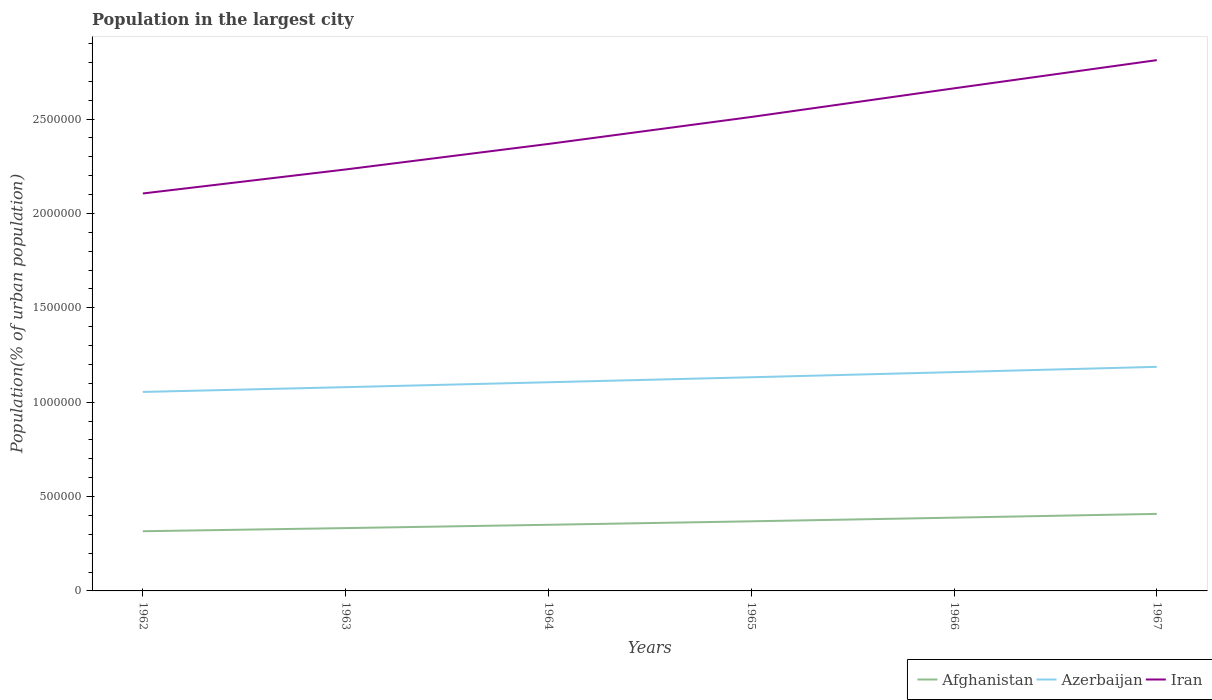How many different coloured lines are there?
Offer a terse response. 3. Does the line corresponding to Afghanistan intersect with the line corresponding to Iran?
Provide a succinct answer. No. Is the number of lines equal to the number of legend labels?
Your answer should be very brief. Yes. Across all years, what is the maximum population in the largest city in Iran?
Keep it short and to the point. 2.11e+06. In which year was the population in the largest city in Afghanistan maximum?
Your response must be concise. 1962. What is the total population in the largest city in Iran in the graph?
Offer a very short reply. -2.78e+05. What is the difference between the highest and the second highest population in the largest city in Azerbaijan?
Ensure brevity in your answer.  1.33e+05. What is the difference between the highest and the lowest population in the largest city in Iran?
Your response must be concise. 3. What is the difference between two consecutive major ticks on the Y-axis?
Ensure brevity in your answer.  5.00e+05. Does the graph contain any zero values?
Make the answer very short. No. How many legend labels are there?
Your response must be concise. 3. What is the title of the graph?
Provide a short and direct response. Population in the largest city. Does "Vietnam" appear as one of the legend labels in the graph?
Make the answer very short. No. What is the label or title of the Y-axis?
Keep it short and to the point. Population(% of urban population). What is the Population(% of urban population) of Afghanistan in 1962?
Offer a terse response. 3.16e+05. What is the Population(% of urban population) of Azerbaijan in 1962?
Make the answer very short. 1.05e+06. What is the Population(% of urban population) of Iran in 1962?
Your answer should be compact. 2.11e+06. What is the Population(% of urban population) of Afghanistan in 1963?
Offer a very short reply. 3.33e+05. What is the Population(% of urban population) of Azerbaijan in 1963?
Provide a succinct answer. 1.08e+06. What is the Population(% of urban population) of Iran in 1963?
Offer a very short reply. 2.23e+06. What is the Population(% of urban population) of Afghanistan in 1964?
Your response must be concise. 3.50e+05. What is the Population(% of urban population) in Azerbaijan in 1964?
Provide a succinct answer. 1.11e+06. What is the Population(% of urban population) of Iran in 1964?
Your answer should be very brief. 2.37e+06. What is the Population(% of urban population) of Afghanistan in 1965?
Provide a succinct answer. 3.69e+05. What is the Population(% of urban population) of Azerbaijan in 1965?
Your answer should be very brief. 1.13e+06. What is the Population(% of urban population) in Iran in 1965?
Offer a terse response. 2.51e+06. What is the Population(% of urban population) of Afghanistan in 1966?
Offer a terse response. 3.88e+05. What is the Population(% of urban population) in Azerbaijan in 1966?
Keep it short and to the point. 1.16e+06. What is the Population(% of urban population) in Iran in 1966?
Offer a very short reply. 2.66e+06. What is the Population(% of urban population) in Afghanistan in 1967?
Ensure brevity in your answer.  4.08e+05. What is the Population(% of urban population) in Azerbaijan in 1967?
Your answer should be very brief. 1.19e+06. What is the Population(% of urban population) of Iran in 1967?
Provide a short and direct response. 2.81e+06. Across all years, what is the maximum Population(% of urban population) of Afghanistan?
Keep it short and to the point. 4.08e+05. Across all years, what is the maximum Population(% of urban population) in Azerbaijan?
Your answer should be very brief. 1.19e+06. Across all years, what is the maximum Population(% of urban population) in Iran?
Keep it short and to the point. 2.81e+06. Across all years, what is the minimum Population(% of urban population) in Afghanistan?
Your answer should be compact. 3.16e+05. Across all years, what is the minimum Population(% of urban population) in Azerbaijan?
Provide a succinct answer. 1.05e+06. Across all years, what is the minimum Population(% of urban population) of Iran?
Your answer should be compact. 2.11e+06. What is the total Population(% of urban population) of Afghanistan in the graph?
Your response must be concise. 2.16e+06. What is the total Population(% of urban population) in Azerbaijan in the graph?
Ensure brevity in your answer.  6.72e+06. What is the total Population(% of urban population) of Iran in the graph?
Make the answer very short. 1.47e+07. What is the difference between the Population(% of urban population) of Afghanistan in 1962 and that in 1963?
Provide a short and direct response. -1.67e+04. What is the difference between the Population(% of urban population) in Azerbaijan in 1962 and that in 1963?
Provide a succinct answer. -2.53e+04. What is the difference between the Population(% of urban population) in Iran in 1962 and that in 1963?
Your response must be concise. -1.27e+05. What is the difference between the Population(% of urban population) of Afghanistan in 1962 and that in 1964?
Keep it short and to the point. -3.42e+04. What is the difference between the Population(% of urban population) in Azerbaijan in 1962 and that in 1964?
Your response must be concise. -5.13e+04. What is the difference between the Population(% of urban population) of Iran in 1962 and that in 1964?
Offer a very short reply. -2.62e+05. What is the difference between the Population(% of urban population) of Afghanistan in 1962 and that in 1965?
Make the answer very short. -5.26e+04. What is the difference between the Population(% of urban population) of Azerbaijan in 1962 and that in 1965?
Your response must be concise. -7.79e+04. What is the difference between the Population(% of urban population) in Iran in 1962 and that in 1965?
Offer a terse response. -4.05e+05. What is the difference between the Population(% of urban population) in Afghanistan in 1962 and that in 1966?
Provide a succinct answer. -7.21e+04. What is the difference between the Population(% of urban population) in Azerbaijan in 1962 and that in 1966?
Make the answer very short. -1.05e+05. What is the difference between the Population(% of urban population) of Iran in 1962 and that in 1966?
Give a very brief answer. -5.57e+05. What is the difference between the Population(% of urban population) in Afghanistan in 1962 and that in 1967?
Provide a short and direct response. -9.19e+04. What is the difference between the Population(% of urban population) of Azerbaijan in 1962 and that in 1967?
Provide a succinct answer. -1.33e+05. What is the difference between the Population(% of urban population) in Iran in 1962 and that in 1967?
Offer a very short reply. -7.06e+05. What is the difference between the Population(% of urban population) in Afghanistan in 1963 and that in 1964?
Your answer should be very brief. -1.76e+04. What is the difference between the Population(% of urban population) in Azerbaijan in 1963 and that in 1964?
Your answer should be very brief. -2.60e+04. What is the difference between the Population(% of urban population) of Iran in 1963 and that in 1964?
Your response must be concise. -1.35e+05. What is the difference between the Population(% of urban population) of Afghanistan in 1963 and that in 1965?
Your answer should be very brief. -3.60e+04. What is the difference between the Population(% of urban population) of Azerbaijan in 1963 and that in 1965?
Ensure brevity in your answer.  -5.25e+04. What is the difference between the Population(% of urban population) in Iran in 1963 and that in 1965?
Your answer should be very brief. -2.78e+05. What is the difference between the Population(% of urban population) of Afghanistan in 1963 and that in 1966?
Ensure brevity in your answer.  -5.54e+04. What is the difference between the Population(% of urban population) in Azerbaijan in 1963 and that in 1966?
Your answer should be compact. -7.97e+04. What is the difference between the Population(% of urban population) of Iran in 1963 and that in 1966?
Give a very brief answer. -4.30e+05. What is the difference between the Population(% of urban population) in Afghanistan in 1963 and that in 1967?
Offer a terse response. -7.53e+04. What is the difference between the Population(% of urban population) in Azerbaijan in 1963 and that in 1967?
Give a very brief answer. -1.08e+05. What is the difference between the Population(% of urban population) in Iran in 1963 and that in 1967?
Make the answer very short. -5.79e+05. What is the difference between the Population(% of urban population) of Afghanistan in 1964 and that in 1965?
Keep it short and to the point. -1.84e+04. What is the difference between the Population(% of urban population) in Azerbaijan in 1964 and that in 1965?
Offer a very short reply. -2.65e+04. What is the difference between the Population(% of urban population) in Iran in 1964 and that in 1965?
Your answer should be very brief. -1.43e+05. What is the difference between the Population(% of urban population) in Afghanistan in 1964 and that in 1966?
Offer a very short reply. -3.78e+04. What is the difference between the Population(% of urban population) in Azerbaijan in 1964 and that in 1966?
Give a very brief answer. -5.37e+04. What is the difference between the Population(% of urban population) in Iran in 1964 and that in 1966?
Offer a terse response. -2.95e+05. What is the difference between the Population(% of urban population) of Afghanistan in 1964 and that in 1967?
Give a very brief answer. -5.77e+04. What is the difference between the Population(% of urban population) of Azerbaijan in 1964 and that in 1967?
Your answer should be compact. -8.16e+04. What is the difference between the Population(% of urban population) of Iran in 1964 and that in 1967?
Offer a terse response. -4.44e+05. What is the difference between the Population(% of urban population) of Afghanistan in 1965 and that in 1966?
Ensure brevity in your answer.  -1.94e+04. What is the difference between the Population(% of urban population) of Azerbaijan in 1965 and that in 1966?
Offer a terse response. -2.72e+04. What is the difference between the Population(% of urban population) in Iran in 1965 and that in 1966?
Offer a very short reply. -1.52e+05. What is the difference between the Population(% of urban population) of Afghanistan in 1965 and that in 1967?
Make the answer very short. -3.93e+04. What is the difference between the Population(% of urban population) of Azerbaijan in 1965 and that in 1967?
Your response must be concise. -5.51e+04. What is the difference between the Population(% of urban population) in Iran in 1965 and that in 1967?
Provide a succinct answer. -3.01e+05. What is the difference between the Population(% of urban population) of Afghanistan in 1966 and that in 1967?
Provide a succinct answer. -1.99e+04. What is the difference between the Population(% of urban population) of Azerbaijan in 1966 and that in 1967?
Make the answer very short. -2.79e+04. What is the difference between the Population(% of urban population) of Iran in 1966 and that in 1967?
Your answer should be very brief. -1.49e+05. What is the difference between the Population(% of urban population) of Afghanistan in 1962 and the Population(% of urban population) of Azerbaijan in 1963?
Provide a short and direct response. -7.63e+05. What is the difference between the Population(% of urban population) of Afghanistan in 1962 and the Population(% of urban population) of Iran in 1963?
Provide a succinct answer. -1.92e+06. What is the difference between the Population(% of urban population) in Azerbaijan in 1962 and the Population(% of urban population) in Iran in 1963?
Provide a short and direct response. -1.18e+06. What is the difference between the Population(% of urban population) in Afghanistan in 1962 and the Population(% of urban population) in Azerbaijan in 1964?
Your response must be concise. -7.89e+05. What is the difference between the Population(% of urban population) in Afghanistan in 1962 and the Population(% of urban population) in Iran in 1964?
Your response must be concise. -2.05e+06. What is the difference between the Population(% of urban population) of Azerbaijan in 1962 and the Population(% of urban population) of Iran in 1964?
Keep it short and to the point. -1.31e+06. What is the difference between the Population(% of urban population) in Afghanistan in 1962 and the Population(% of urban population) in Azerbaijan in 1965?
Provide a succinct answer. -8.16e+05. What is the difference between the Population(% of urban population) in Afghanistan in 1962 and the Population(% of urban population) in Iran in 1965?
Your response must be concise. -2.19e+06. What is the difference between the Population(% of urban population) in Azerbaijan in 1962 and the Population(% of urban population) in Iran in 1965?
Provide a short and direct response. -1.46e+06. What is the difference between the Population(% of urban population) of Afghanistan in 1962 and the Population(% of urban population) of Azerbaijan in 1966?
Your answer should be compact. -8.43e+05. What is the difference between the Population(% of urban population) in Afghanistan in 1962 and the Population(% of urban population) in Iran in 1966?
Provide a short and direct response. -2.35e+06. What is the difference between the Population(% of urban population) of Azerbaijan in 1962 and the Population(% of urban population) of Iran in 1966?
Provide a short and direct response. -1.61e+06. What is the difference between the Population(% of urban population) in Afghanistan in 1962 and the Population(% of urban population) in Azerbaijan in 1967?
Give a very brief answer. -8.71e+05. What is the difference between the Population(% of urban population) of Afghanistan in 1962 and the Population(% of urban population) of Iran in 1967?
Give a very brief answer. -2.50e+06. What is the difference between the Population(% of urban population) in Azerbaijan in 1962 and the Population(% of urban population) in Iran in 1967?
Keep it short and to the point. -1.76e+06. What is the difference between the Population(% of urban population) of Afghanistan in 1963 and the Population(% of urban population) of Azerbaijan in 1964?
Provide a succinct answer. -7.73e+05. What is the difference between the Population(% of urban population) of Afghanistan in 1963 and the Population(% of urban population) of Iran in 1964?
Offer a very short reply. -2.04e+06. What is the difference between the Population(% of urban population) of Azerbaijan in 1963 and the Population(% of urban population) of Iran in 1964?
Provide a succinct answer. -1.29e+06. What is the difference between the Population(% of urban population) of Afghanistan in 1963 and the Population(% of urban population) of Azerbaijan in 1965?
Provide a succinct answer. -7.99e+05. What is the difference between the Population(% of urban population) in Afghanistan in 1963 and the Population(% of urban population) in Iran in 1965?
Provide a succinct answer. -2.18e+06. What is the difference between the Population(% of urban population) of Azerbaijan in 1963 and the Population(% of urban population) of Iran in 1965?
Make the answer very short. -1.43e+06. What is the difference between the Population(% of urban population) of Afghanistan in 1963 and the Population(% of urban population) of Azerbaijan in 1966?
Give a very brief answer. -8.26e+05. What is the difference between the Population(% of urban population) of Afghanistan in 1963 and the Population(% of urban population) of Iran in 1966?
Give a very brief answer. -2.33e+06. What is the difference between the Population(% of urban population) in Azerbaijan in 1963 and the Population(% of urban population) in Iran in 1966?
Provide a succinct answer. -1.58e+06. What is the difference between the Population(% of urban population) in Afghanistan in 1963 and the Population(% of urban population) in Azerbaijan in 1967?
Your response must be concise. -8.54e+05. What is the difference between the Population(% of urban population) of Afghanistan in 1963 and the Population(% of urban population) of Iran in 1967?
Your response must be concise. -2.48e+06. What is the difference between the Population(% of urban population) in Azerbaijan in 1963 and the Population(% of urban population) in Iran in 1967?
Keep it short and to the point. -1.73e+06. What is the difference between the Population(% of urban population) in Afghanistan in 1964 and the Population(% of urban population) in Azerbaijan in 1965?
Offer a terse response. -7.82e+05. What is the difference between the Population(% of urban population) in Afghanistan in 1964 and the Population(% of urban population) in Iran in 1965?
Provide a short and direct response. -2.16e+06. What is the difference between the Population(% of urban population) in Azerbaijan in 1964 and the Population(% of urban population) in Iran in 1965?
Your answer should be very brief. -1.41e+06. What is the difference between the Population(% of urban population) of Afghanistan in 1964 and the Population(% of urban population) of Azerbaijan in 1966?
Make the answer very short. -8.09e+05. What is the difference between the Population(% of urban population) of Afghanistan in 1964 and the Population(% of urban population) of Iran in 1966?
Your response must be concise. -2.31e+06. What is the difference between the Population(% of urban population) in Azerbaijan in 1964 and the Population(% of urban population) in Iran in 1966?
Offer a very short reply. -1.56e+06. What is the difference between the Population(% of urban population) of Afghanistan in 1964 and the Population(% of urban population) of Azerbaijan in 1967?
Provide a short and direct response. -8.37e+05. What is the difference between the Population(% of urban population) of Afghanistan in 1964 and the Population(% of urban population) of Iran in 1967?
Ensure brevity in your answer.  -2.46e+06. What is the difference between the Population(% of urban population) of Azerbaijan in 1964 and the Population(% of urban population) of Iran in 1967?
Provide a short and direct response. -1.71e+06. What is the difference between the Population(% of urban population) of Afghanistan in 1965 and the Population(% of urban population) of Azerbaijan in 1966?
Ensure brevity in your answer.  -7.90e+05. What is the difference between the Population(% of urban population) in Afghanistan in 1965 and the Population(% of urban population) in Iran in 1966?
Provide a succinct answer. -2.29e+06. What is the difference between the Population(% of urban population) of Azerbaijan in 1965 and the Population(% of urban population) of Iran in 1966?
Offer a very short reply. -1.53e+06. What is the difference between the Population(% of urban population) of Afghanistan in 1965 and the Population(% of urban population) of Azerbaijan in 1967?
Ensure brevity in your answer.  -8.18e+05. What is the difference between the Population(% of urban population) in Afghanistan in 1965 and the Population(% of urban population) in Iran in 1967?
Provide a short and direct response. -2.44e+06. What is the difference between the Population(% of urban population) of Azerbaijan in 1965 and the Population(% of urban population) of Iran in 1967?
Make the answer very short. -1.68e+06. What is the difference between the Population(% of urban population) in Afghanistan in 1966 and the Population(% of urban population) in Azerbaijan in 1967?
Give a very brief answer. -7.99e+05. What is the difference between the Population(% of urban population) of Afghanistan in 1966 and the Population(% of urban population) of Iran in 1967?
Offer a very short reply. -2.42e+06. What is the difference between the Population(% of urban population) in Azerbaijan in 1966 and the Population(% of urban population) in Iran in 1967?
Make the answer very short. -1.65e+06. What is the average Population(% of urban population) in Afghanistan per year?
Offer a terse response. 3.61e+05. What is the average Population(% of urban population) in Azerbaijan per year?
Your answer should be very brief. 1.12e+06. What is the average Population(% of urban population) in Iran per year?
Provide a short and direct response. 2.45e+06. In the year 1962, what is the difference between the Population(% of urban population) in Afghanistan and Population(% of urban population) in Azerbaijan?
Provide a short and direct response. -7.38e+05. In the year 1962, what is the difference between the Population(% of urban population) in Afghanistan and Population(% of urban population) in Iran?
Provide a short and direct response. -1.79e+06. In the year 1962, what is the difference between the Population(% of urban population) of Azerbaijan and Population(% of urban population) of Iran?
Offer a terse response. -1.05e+06. In the year 1963, what is the difference between the Population(% of urban population) of Afghanistan and Population(% of urban population) of Azerbaijan?
Your answer should be very brief. -7.47e+05. In the year 1963, what is the difference between the Population(% of urban population) of Afghanistan and Population(% of urban population) of Iran?
Provide a succinct answer. -1.90e+06. In the year 1963, what is the difference between the Population(% of urban population) in Azerbaijan and Population(% of urban population) in Iran?
Ensure brevity in your answer.  -1.15e+06. In the year 1964, what is the difference between the Population(% of urban population) of Afghanistan and Population(% of urban population) of Azerbaijan?
Offer a terse response. -7.55e+05. In the year 1964, what is the difference between the Population(% of urban population) in Afghanistan and Population(% of urban population) in Iran?
Your answer should be compact. -2.02e+06. In the year 1964, what is the difference between the Population(% of urban population) in Azerbaijan and Population(% of urban population) in Iran?
Your answer should be very brief. -1.26e+06. In the year 1965, what is the difference between the Population(% of urban population) of Afghanistan and Population(% of urban population) of Azerbaijan?
Ensure brevity in your answer.  -7.63e+05. In the year 1965, what is the difference between the Population(% of urban population) in Afghanistan and Population(% of urban population) in Iran?
Your response must be concise. -2.14e+06. In the year 1965, what is the difference between the Population(% of urban population) of Azerbaijan and Population(% of urban population) of Iran?
Ensure brevity in your answer.  -1.38e+06. In the year 1966, what is the difference between the Population(% of urban population) of Afghanistan and Population(% of urban population) of Azerbaijan?
Your answer should be very brief. -7.71e+05. In the year 1966, what is the difference between the Population(% of urban population) of Afghanistan and Population(% of urban population) of Iran?
Ensure brevity in your answer.  -2.27e+06. In the year 1966, what is the difference between the Population(% of urban population) of Azerbaijan and Population(% of urban population) of Iran?
Your answer should be compact. -1.50e+06. In the year 1967, what is the difference between the Population(% of urban population) in Afghanistan and Population(% of urban population) in Azerbaijan?
Give a very brief answer. -7.79e+05. In the year 1967, what is the difference between the Population(% of urban population) of Afghanistan and Population(% of urban population) of Iran?
Make the answer very short. -2.40e+06. In the year 1967, what is the difference between the Population(% of urban population) of Azerbaijan and Population(% of urban population) of Iran?
Your answer should be compact. -1.62e+06. What is the ratio of the Population(% of urban population) of Afghanistan in 1962 to that in 1963?
Make the answer very short. 0.95. What is the ratio of the Population(% of urban population) in Azerbaijan in 1962 to that in 1963?
Provide a succinct answer. 0.98. What is the ratio of the Population(% of urban population) of Iran in 1962 to that in 1963?
Make the answer very short. 0.94. What is the ratio of the Population(% of urban population) of Afghanistan in 1962 to that in 1964?
Your answer should be compact. 0.9. What is the ratio of the Population(% of urban population) in Azerbaijan in 1962 to that in 1964?
Ensure brevity in your answer.  0.95. What is the ratio of the Population(% of urban population) of Iran in 1962 to that in 1964?
Give a very brief answer. 0.89. What is the ratio of the Population(% of urban population) in Afghanistan in 1962 to that in 1965?
Give a very brief answer. 0.86. What is the ratio of the Population(% of urban population) in Azerbaijan in 1962 to that in 1965?
Make the answer very short. 0.93. What is the ratio of the Population(% of urban population) of Iran in 1962 to that in 1965?
Make the answer very short. 0.84. What is the ratio of the Population(% of urban population) in Afghanistan in 1962 to that in 1966?
Offer a terse response. 0.81. What is the ratio of the Population(% of urban population) in Azerbaijan in 1962 to that in 1966?
Offer a very short reply. 0.91. What is the ratio of the Population(% of urban population) in Iran in 1962 to that in 1966?
Your answer should be compact. 0.79. What is the ratio of the Population(% of urban population) in Afghanistan in 1962 to that in 1967?
Offer a terse response. 0.77. What is the ratio of the Population(% of urban population) of Azerbaijan in 1962 to that in 1967?
Provide a short and direct response. 0.89. What is the ratio of the Population(% of urban population) of Iran in 1962 to that in 1967?
Keep it short and to the point. 0.75. What is the ratio of the Population(% of urban population) of Afghanistan in 1963 to that in 1964?
Offer a very short reply. 0.95. What is the ratio of the Population(% of urban population) in Azerbaijan in 1963 to that in 1964?
Your response must be concise. 0.98. What is the ratio of the Population(% of urban population) of Iran in 1963 to that in 1964?
Your response must be concise. 0.94. What is the ratio of the Population(% of urban population) in Afghanistan in 1963 to that in 1965?
Keep it short and to the point. 0.9. What is the ratio of the Population(% of urban population) in Azerbaijan in 1963 to that in 1965?
Make the answer very short. 0.95. What is the ratio of the Population(% of urban population) of Iran in 1963 to that in 1965?
Make the answer very short. 0.89. What is the ratio of the Population(% of urban population) in Afghanistan in 1963 to that in 1966?
Provide a short and direct response. 0.86. What is the ratio of the Population(% of urban population) in Azerbaijan in 1963 to that in 1966?
Keep it short and to the point. 0.93. What is the ratio of the Population(% of urban population) in Iran in 1963 to that in 1966?
Give a very brief answer. 0.84. What is the ratio of the Population(% of urban population) of Afghanistan in 1963 to that in 1967?
Give a very brief answer. 0.82. What is the ratio of the Population(% of urban population) in Azerbaijan in 1963 to that in 1967?
Give a very brief answer. 0.91. What is the ratio of the Population(% of urban population) of Iran in 1963 to that in 1967?
Give a very brief answer. 0.79. What is the ratio of the Population(% of urban population) in Azerbaijan in 1964 to that in 1965?
Provide a short and direct response. 0.98. What is the ratio of the Population(% of urban population) in Iran in 1964 to that in 1965?
Offer a terse response. 0.94. What is the ratio of the Population(% of urban population) of Afghanistan in 1964 to that in 1966?
Offer a very short reply. 0.9. What is the ratio of the Population(% of urban population) of Azerbaijan in 1964 to that in 1966?
Your answer should be very brief. 0.95. What is the ratio of the Population(% of urban population) of Iran in 1964 to that in 1966?
Ensure brevity in your answer.  0.89. What is the ratio of the Population(% of urban population) of Afghanistan in 1964 to that in 1967?
Offer a terse response. 0.86. What is the ratio of the Population(% of urban population) in Azerbaijan in 1964 to that in 1967?
Keep it short and to the point. 0.93. What is the ratio of the Population(% of urban population) in Iran in 1964 to that in 1967?
Provide a short and direct response. 0.84. What is the ratio of the Population(% of urban population) in Afghanistan in 1965 to that in 1966?
Provide a succinct answer. 0.95. What is the ratio of the Population(% of urban population) in Azerbaijan in 1965 to that in 1966?
Make the answer very short. 0.98. What is the ratio of the Population(% of urban population) in Iran in 1965 to that in 1966?
Give a very brief answer. 0.94. What is the ratio of the Population(% of urban population) in Afghanistan in 1965 to that in 1967?
Offer a very short reply. 0.9. What is the ratio of the Population(% of urban population) of Azerbaijan in 1965 to that in 1967?
Give a very brief answer. 0.95. What is the ratio of the Population(% of urban population) of Iran in 1965 to that in 1967?
Your answer should be compact. 0.89. What is the ratio of the Population(% of urban population) in Afghanistan in 1966 to that in 1967?
Keep it short and to the point. 0.95. What is the ratio of the Population(% of urban population) of Azerbaijan in 1966 to that in 1967?
Your answer should be compact. 0.98. What is the ratio of the Population(% of urban population) in Iran in 1966 to that in 1967?
Offer a terse response. 0.95. What is the difference between the highest and the second highest Population(% of urban population) in Afghanistan?
Provide a short and direct response. 1.99e+04. What is the difference between the highest and the second highest Population(% of urban population) in Azerbaijan?
Your answer should be very brief. 2.79e+04. What is the difference between the highest and the second highest Population(% of urban population) in Iran?
Provide a succinct answer. 1.49e+05. What is the difference between the highest and the lowest Population(% of urban population) in Afghanistan?
Provide a short and direct response. 9.19e+04. What is the difference between the highest and the lowest Population(% of urban population) in Azerbaijan?
Ensure brevity in your answer.  1.33e+05. What is the difference between the highest and the lowest Population(% of urban population) in Iran?
Give a very brief answer. 7.06e+05. 